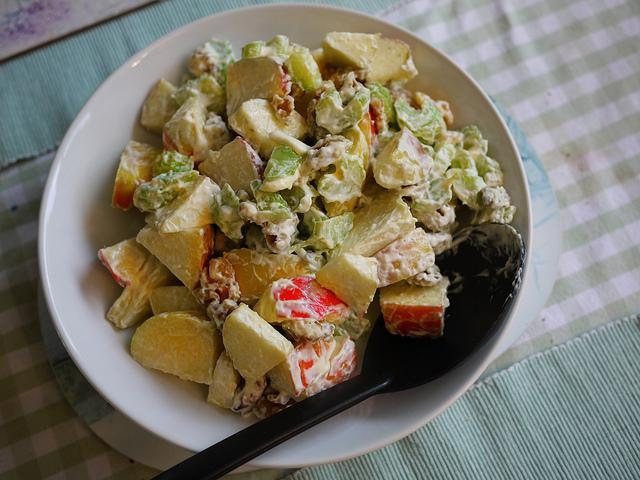What type of utensil is in the bowl? spoon 